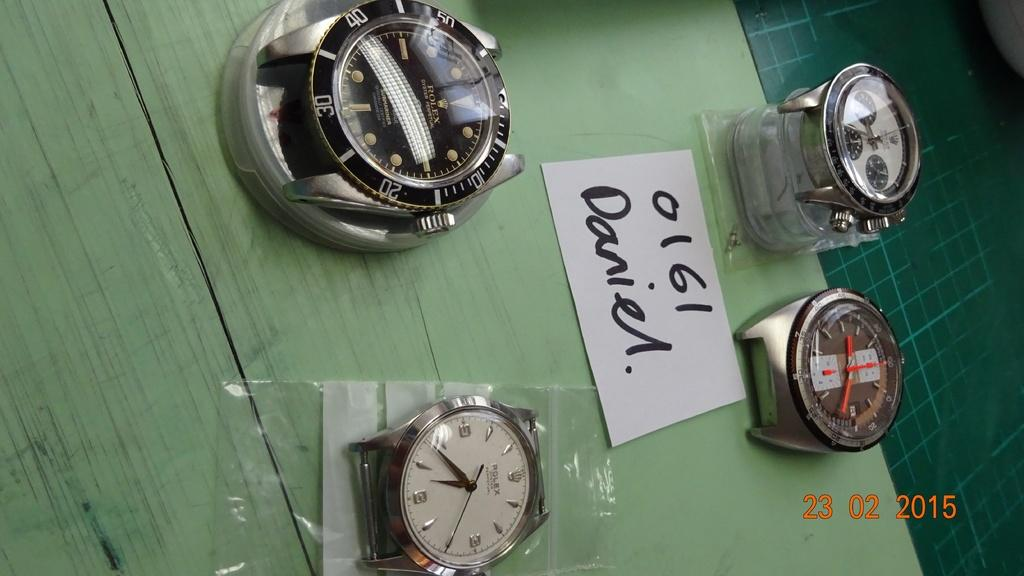<image>
Summarize the visual content of the image. Four watches sit on a table including at least two Rolex. 